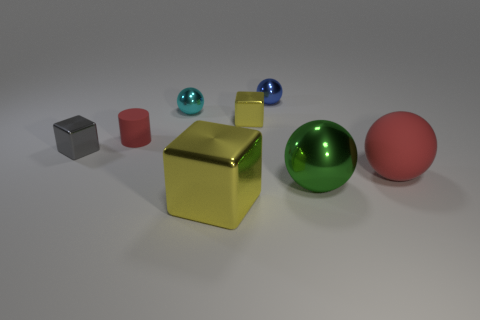There is another rubber object that is the same color as the big rubber object; what size is it?
Offer a very short reply. Small. How many gray things are either large objects or matte things?
Offer a very short reply. 0. Are there any green objects left of the tiny block that is left of the yellow metal thing in front of the tiny yellow shiny cube?
Ensure brevity in your answer.  No. The rubber thing that is the same color as the matte sphere is what shape?
Ensure brevity in your answer.  Cylinder. Is there anything else that has the same material as the small yellow object?
Provide a short and direct response. Yes. What number of large objects are gray cubes or blue balls?
Offer a terse response. 0. Does the yellow thing that is to the right of the large yellow block have the same shape as the large green object?
Ensure brevity in your answer.  No. Is the number of brown objects less than the number of green objects?
Keep it short and to the point. Yes. Is there anything else that is the same color as the large metallic ball?
Make the answer very short. No. What is the shape of the rubber object on the right side of the green thing?
Offer a terse response. Sphere. 